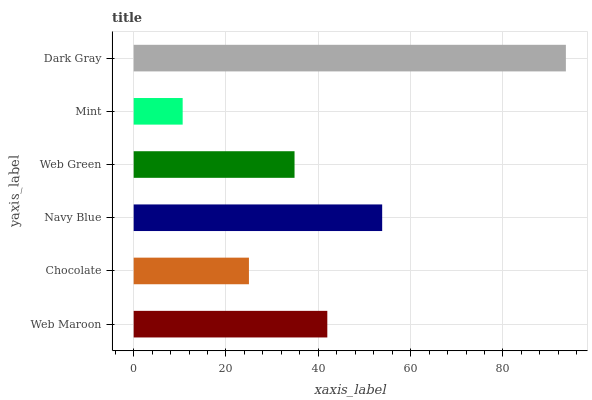Is Mint the minimum?
Answer yes or no. Yes. Is Dark Gray the maximum?
Answer yes or no. Yes. Is Chocolate the minimum?
Answer yes or no. No. Is Chocolate the maximum?
Answer yes or no. No. Is Web Maroon greater than Chocolate?
Answer yes or no. Yes. Is Chocolate less than Web Maroon?
Answer yes or no. Yes. Is Chocolate greater than Web Maroon?
Answer yes or no. No. Is Web Maroon less than Chocolate?
Answer yes or no. No. Is Web Maroon the high median?
Answer yes or no. Yes. Is Web Green the low median?
Answer yes or no. Yes. Is Navy Blue the high median?
Answer yes or no. No. Is Chocolate the low median?
Answer yes or no. No. 